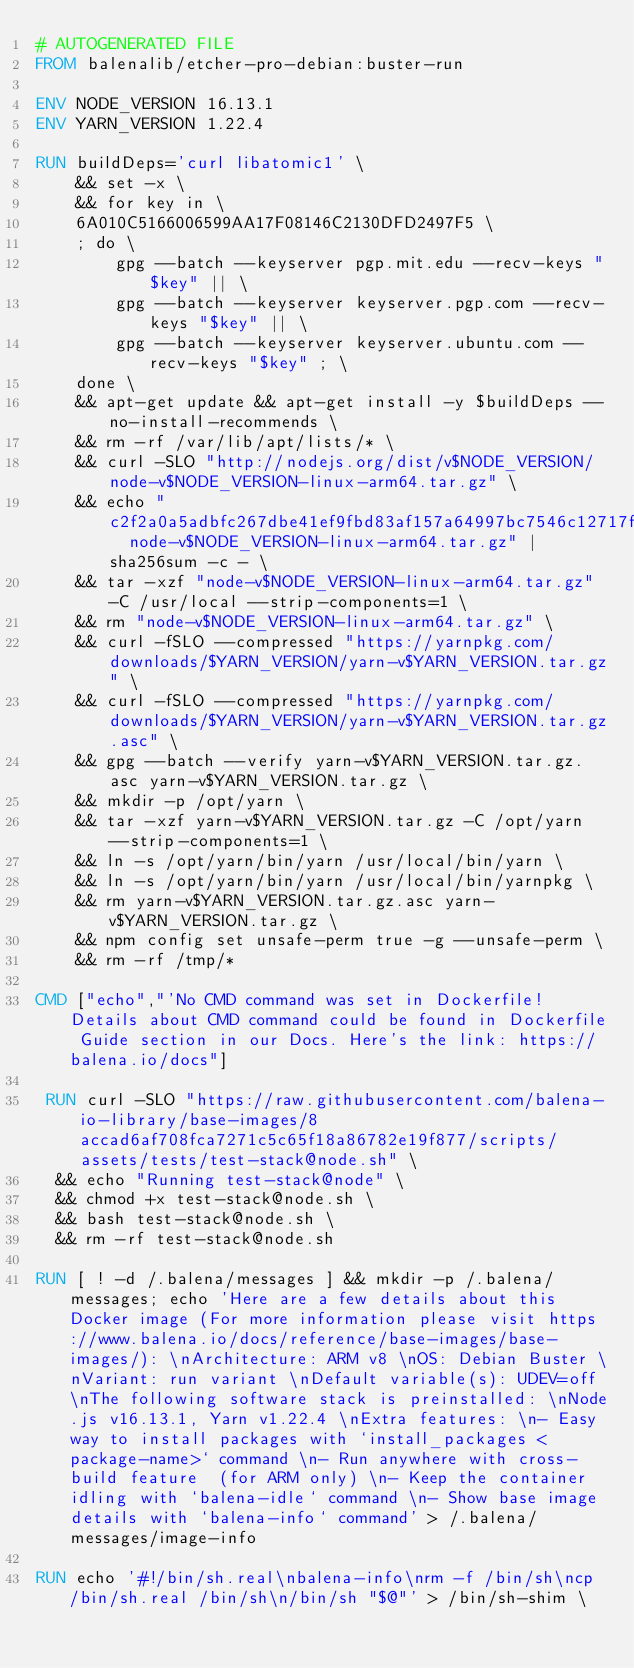<code> <loc_0><loc_0><loc_500><loc_500><_Dockerfile_># AUTOGENERATED FILE
FROM balenalib/etcher-pro-debian:buster-run

ENV NODE_VERSION 16.13.1
ENV YARN_VERSION 1.22.4

RUN buildDeps='curl libatomic1' \
	&& set -x \
	&& for key in \
	6A010C5166006599AA17F08146C2130DFD2497F5 \
	; do \
		gpg --batch --keyserver pgp.mit.edu --recv-keys "$key" || \
		gpg --batch --keyserver keyserver.pgp.com --recv-keys "$key" || \
		gpg --batch --keyserver keyserver.ubuntu.com --recv-keys "$key" ; \
	done \
	&& apt-get update && apt-get install -y $buildDeps --no-install-recommends \
	&& rm -rf /var/lib/apt/lists/* \
	&& curl -SLO "http://nodejs.org/dist/v$NODE_VERSION/node-v$NODE_VERSION-linux-arm64.tar.gz" \
	&& echo "c2f2a0a5adbfc267dbe41ef9fbd83af157a64997bc7546c12717ff55ea6b57d8  node-v$NODE_VERSION-linux-arm64.tar.gz" | sha256sum -c - \
	&& tar -xzf "node-v$NODE_VERSION-linux-arm64.tar.gz" -C /usr/local --strip-components=1 \
	&& rm "node-v$NODE_VERSION-linux-arm64.tar.gz" \
	&& curl -fSLO --compressed "https://yarnpkg.com/downloads/$YARN_VERSION/yarn-v$YARN_VERSION.tar.gz" \
	&& curl -fSLO --compressed "https://yarnpkg.com/downloads/$YARN_VERSION/yarn-v$YARN_VERSION.tar.gz.asc" \
	&& gpg --batch --verify yarn-v$YARN_VERSION.tar.gz.asc yarn-v$YARN_VERSION.tar.gz \
	&& mkdir -p /opt/yarn \
	&& tar -xzf yarn-v$YARN_VERSION.tar.gz -C /opt/yarn --strip-components=1 \
	&& ln -s /opt/yarn/bin/yarn /usr/local/bin/yarn \
	&& ln -s /opt/yarn/bin/yarn /usr/local/bin/yarnpkg \
	&& rm yarn-v$YARN_VERSION.tar.gz.asc yarn-v$YARN_VERSION.tar.gz \
	&& npm config set unsafe-perm true -g --unsafe-perm \
	&& rm -rf /tmp/*

CMD ["echo","'No CMD command was set in Dockerfile! Details about CMD command could be found in Dockerfile Guide section in our Docs. Here's the link: https://balena.io/docs"]

 RUN curl -SLO "https://raw.githubusercontent.com/balena-io-library/base-images/8accad6af708fca7271c5c65f18a86782e19f877/scripts/assets/tests/test-stack@node.sh" \
  && echo "Running test-stack@node" \
  && chmod +x test-stack@node.sh \
  && bash test-stack@node.sh \
  && rm -rf test-stack@node.sh 

RUN [ ! -d /.balena/messages ] && mkdir -p /.balena/messages; echo 'Here are a few details about this Docker image (For more information please visit https://www.balena.io/docs/reference/base-images/base-images/): \nArchitecture: ARM v8 \nOS: Debian Buster \nVariant: run variant \nDefault variable(s): UDEV=off \nThe following software stack is preinstalled: \nNode.js v16.13.1, Yarn v1.22.4 \nExtra features: \n- Easy way to install packages with `install_packages <package-name>` command \n- Run anywhere with cross-build feature  (for ARM only) \n- Keep the container idling with `balena-idle` command \n- Show base image details with `balena-info` command' > /.balena/messages/image-info

RUN echo '#!/bin/sh.real\nbalena-info\nrm -f /bin/sh\ncp /bin/sh.real /bin/sh\n/bin/sh "$@"' > /bin/sh-shim \</code> 